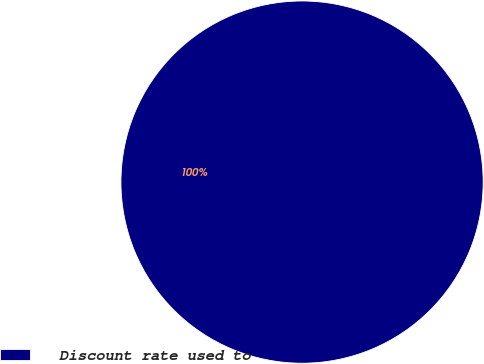<chart> <loc_0><loc_0><loc_500><loc_500><pie_chart><fcel>Discount rate used to<nl><fcel>100.0%<nl></chart> 